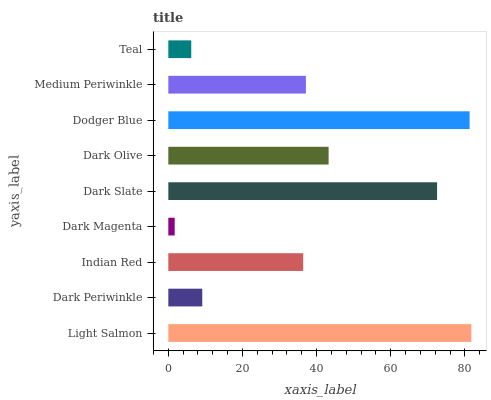Is Dark Magenta the minimum?
Answer yes or no. Yes. Is Light Salmon the maximum?
Answer yes or no. Yes. Is Dark Periwinkle the minimum?
Answer yes or no. No. Is Dark Periwinkle the maximum?
Answer yes or no. No. Is Light Salmon greater than Dark Periwinkle?
Answer yes or no. Yes. Is Dark Periwinkle less than Light Salmon?
Answer yes or no. Yes. Is Dark Periwinkle greater than Light Salmon?
Answer yes or no. No. Is Light Salmon less than Dark Periwinkle?
Answer yes or no. No. Is Medium Periwinkle the high median?
Answer yes or no. Yes. Is Medium Periwinkle the low median?
Answer yes or no. Yes. Is Dark Olive the high median?
Answer yes or no. No. Is Light Salmon the low median?
Answer yes or no. No. 